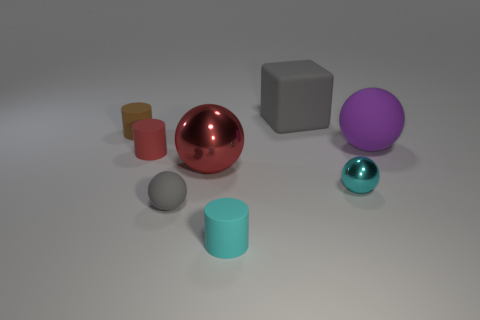Are there any other big cubes of the same color as the matte block?
Offer a very short reply. No. How many shiny objects are left of the tiny gray object?
Keep it short and to the point. 0. How many other objects are the same size as the red cylinder?
Provide a short and direct response. 4. Does the large red object in front of the brown rubber thing have the same material as the gray thing that is left of the large matte cube?
Keep it short and to the point. No. There is a matte ball that is the same size as the block; what is its color?
Provide a short and direct response. Purple. Is there any other thing that has the same color as the block?
Make the answer very short. Yes. How big is the rubber cylinder in front of the cyan thing right of the cylinder in front of the big red thing?
Offer a terse response. Small. What is the color of the sphere that is right of the big gray block and in front of the red metallic thing?
Your response must be concise. Cyan. There is a rubber cylinder that is right of the tiny red cylinder; what is its size?
Keep it short and to the point. Small. How many gray spheres have the same material as the small cyan sphere?
Make the answer very short. 0. 